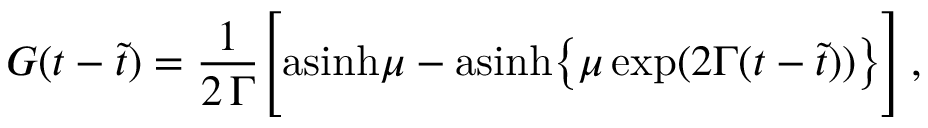Convert formula to latex. <formula><loc_0><loc_0><loc_500><loc_500>G ( t - \tilde { t } ) = { \frac { 1 } { 2 \, \Gamma } } \left [ a \sinh \mu - a \sinh \left \{ \mu \, e x p ( 2 \Gamma ( t - \tilde { t } ) ) \right \} \right ] \, ,</formula> 